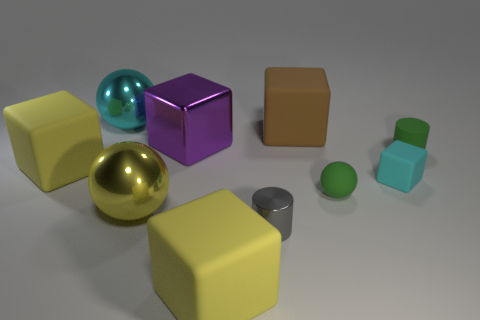Subtract all big balls. How many balls are left? 1 Subtract all brown cubes. How many cubes are left? 4 Subtract all cylinders. How many objects are left? 8 Subtract all gray cylinders. How many purple cubes are left? 1 Subtract all large cylinders. Subtract all cyan spheres. How many objects are left? 9 Add 2 big yellow metal objects. How many big yellow metal objects are left? 3 Add 8 large shiny balls. How many large shiny balls exist? 10 Subtract 0 cyan cylinders. How many objects are left? 10 Subtract 1 blocks. How many blocks are left? 4 Subtract all cyan cubes. Subtract all red spheres. How many cubes are left? 4 